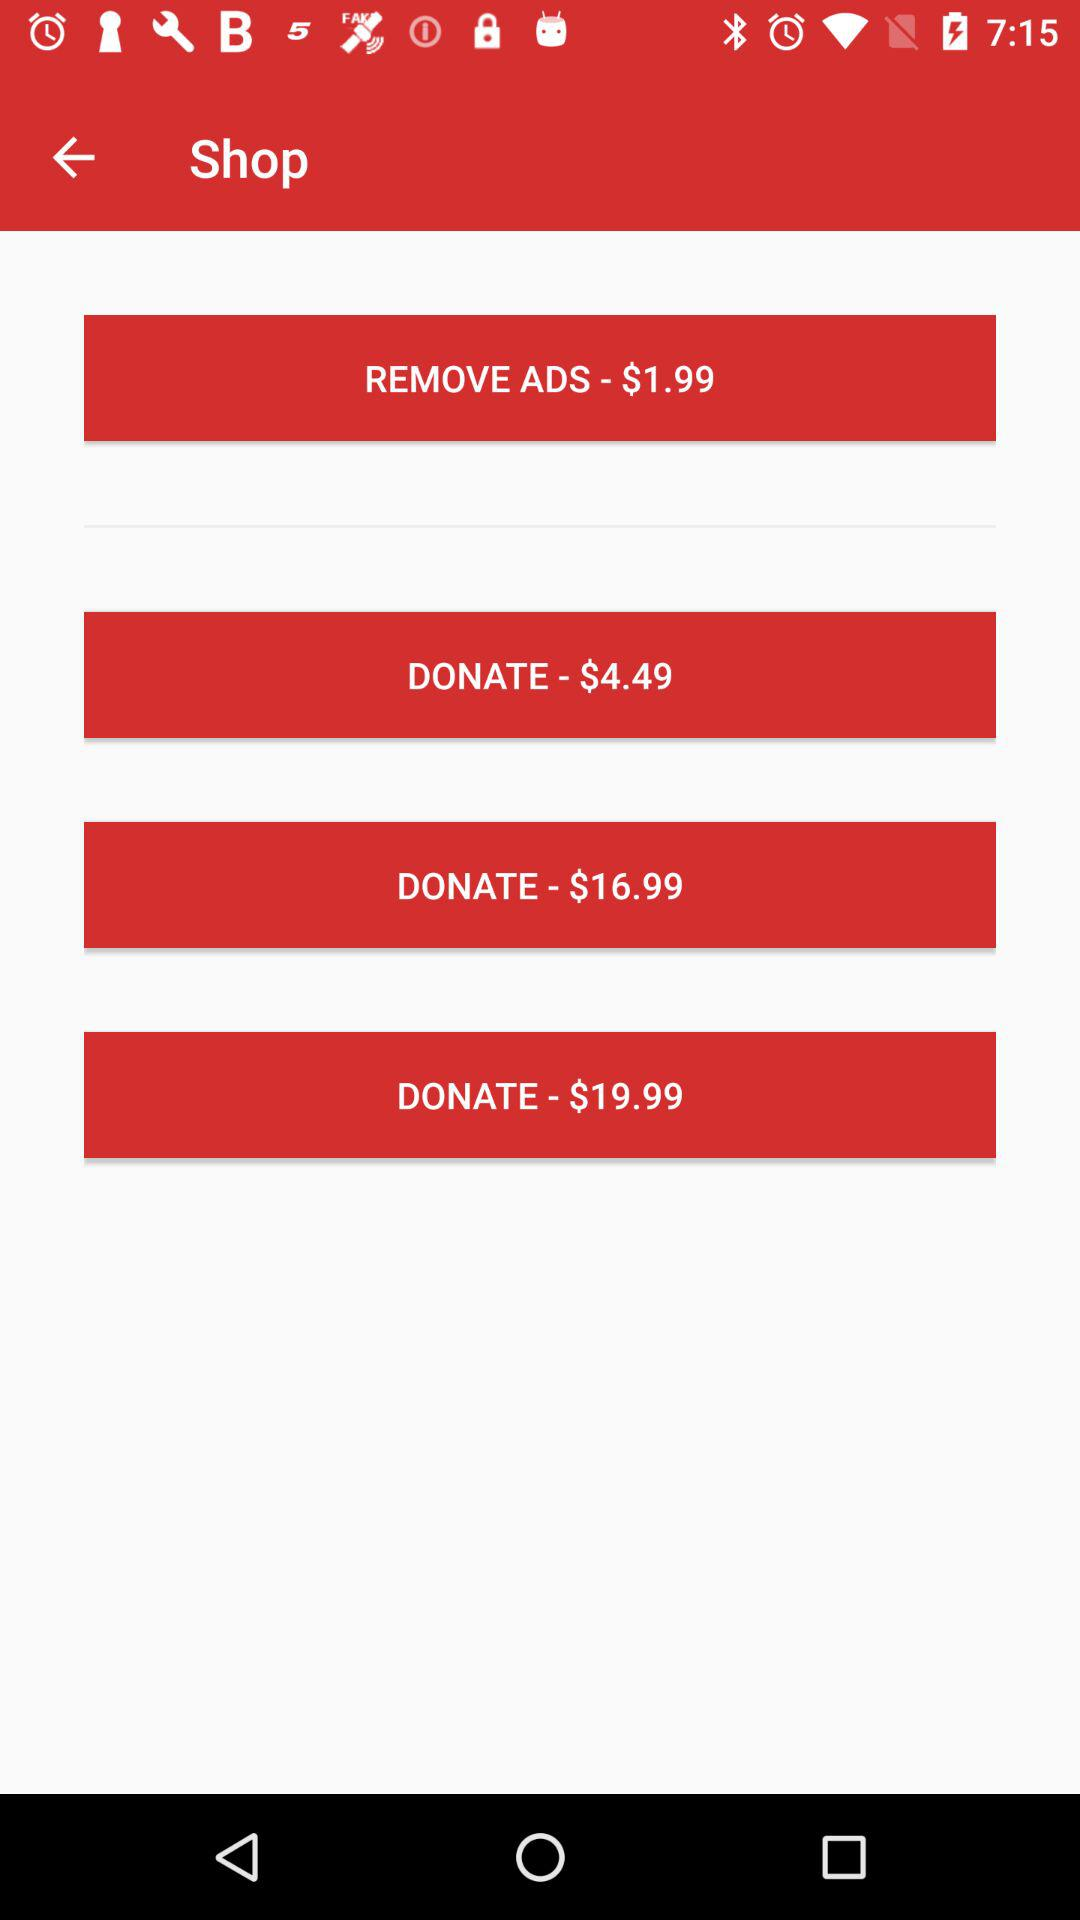How much more expensive is the $19.99 donation than the $4.49 donation?
Answer the question using a single word or phrase. $15.50 